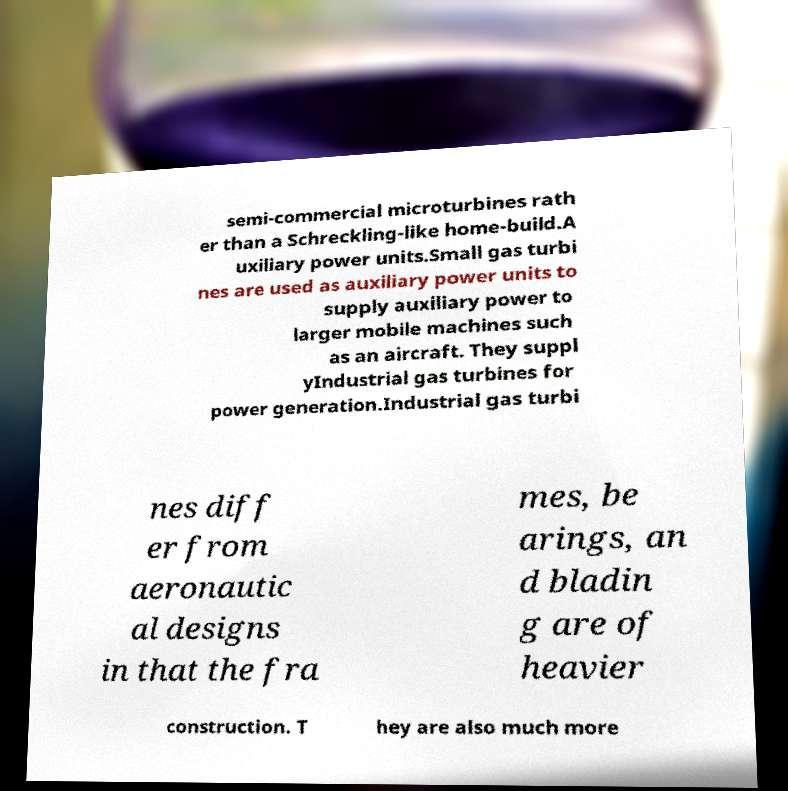Could you assist in decoding the text presented in this image and type it out clearly? semi-commercial microturbines rath er than a Schreckling-like home-build.A uxiliary power units.Small gas turbi nes are used as auxiliary power units to supply auxiliary power to larger mobile machines such as an aircraft. They suppl yIndustrial gas turbines for power generation.Industrial gas turbi nes diff er from aeronautic al designs in that the fra mes, be arings, an d bladin g are of heavier construction. T hey are also much more 